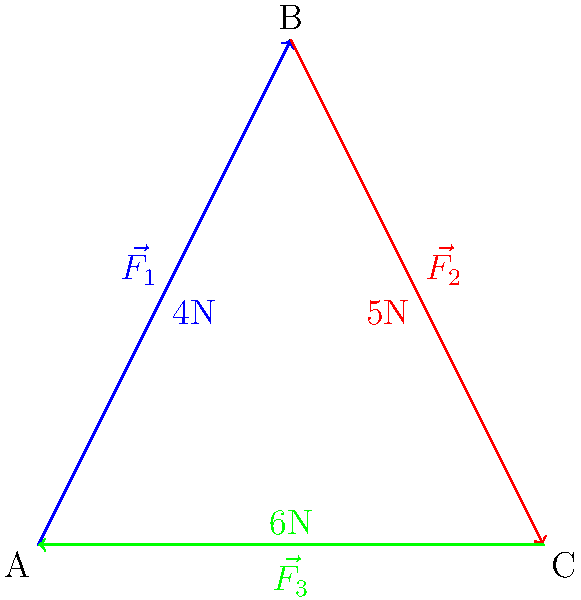In a biomechanical analysis of a squat exercise, three force vectors $\vec{F_1}$, $\vec{F_2}$, and $\vec{F_3}$ are acting on a joint as shown in the diagram. Given that $|\vec{F_1}| = 4N$, $|\vec{F_2}| = 5N$, and $|\vec{F_3}| = 6N$, calculate the magnitude of the resultant force vector $\vec{R}$ using vector addition. Round your answer to two decimal places. To solve this problem, we'll use the following steps:

1) First, we need to determine the components of each force vector. We can do this by using the properties of right triangles:

   $\vec{F_1}$: x-component = 2N, y-component = 4N
   $\vec{F_2}$: x-component = 4N, y-component = -3N
   $\vec{F_3}$: x-component = -6N, y-component = 0N

2) Now, we can add up all the x-components and y-components separately:

   Total x-component: 2N + 4N + (-6N) = 0N
   Total y-component: 4N + (-3N) + 0N = 1N

3) The resultant force vector $\vec{R}$ has these components: (0N, 1N)

4) To find the magnitude of $\vec{R}$, we use the Pythagorean theorem:

   $|\vec{R}| = \sqrt{x^2 + y^2} = \sqrt{0^2 + 1^2} = \sqrt{1} = 1N$

5) The question asks for the answer rounded to two decimal places, so our final answer is 1.00N.
Answer: 1.00N 